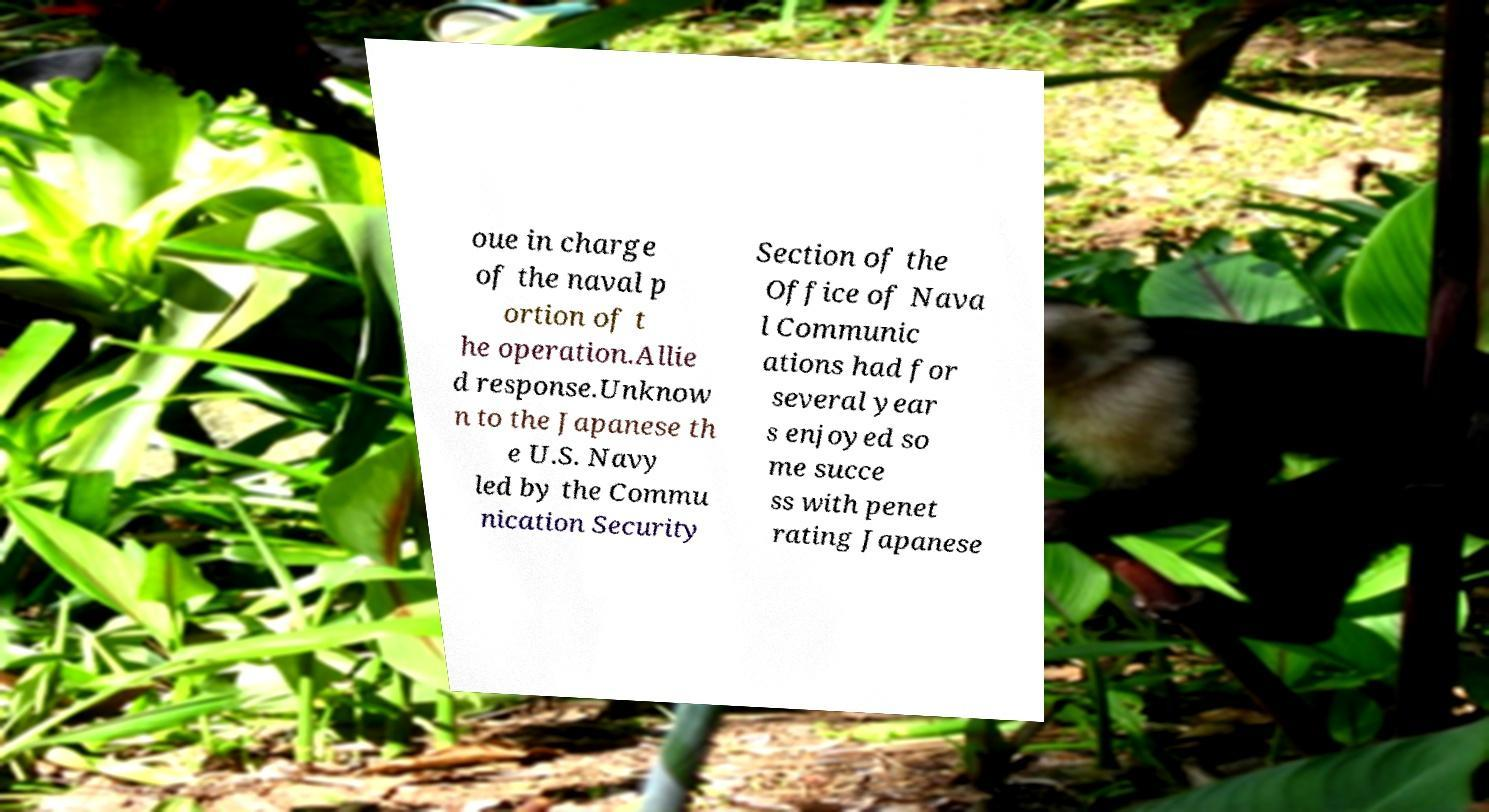Please read and relay the text visible in this image. What does it say? oue in charge of the naval p ortion of t he operation.Allie d response.Unknow n to the Japanese th e U.S. Navy led by the Commu nication Security Section of the Office of Nava l Communic ations had for several year s enjoyed so me succe ss with penet rating Japanese 